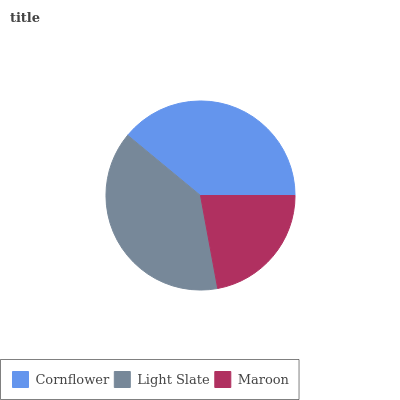Is Maroon the minimum?
Answer yes or no. Yes. Is Cornflower the maximum?
Answer yes or no. Yes. Is Light Slate the minimum?
Answer yes or no. No. Is Light Slate the maximum?
Answer yes or no. No. Is Cornflower greater than Light Slate?
Answer yes or no. Yes. Is Light Slate less than Cornflower?
Answer yes or no. Yes. Is Light Slate greater than Cornflower?
Answer yes or no. No. Is Cornflower less than Light Slate?
Answer yes or no. No. Is Light Slate the high median?
Answer yes or no. Yes. Is Light Slate the low median?
Answer yes or no. Yes. Is Maroon the high median?
Answer yes or no. No. Is Cornflower the low median?
Answer yes or no. No. 